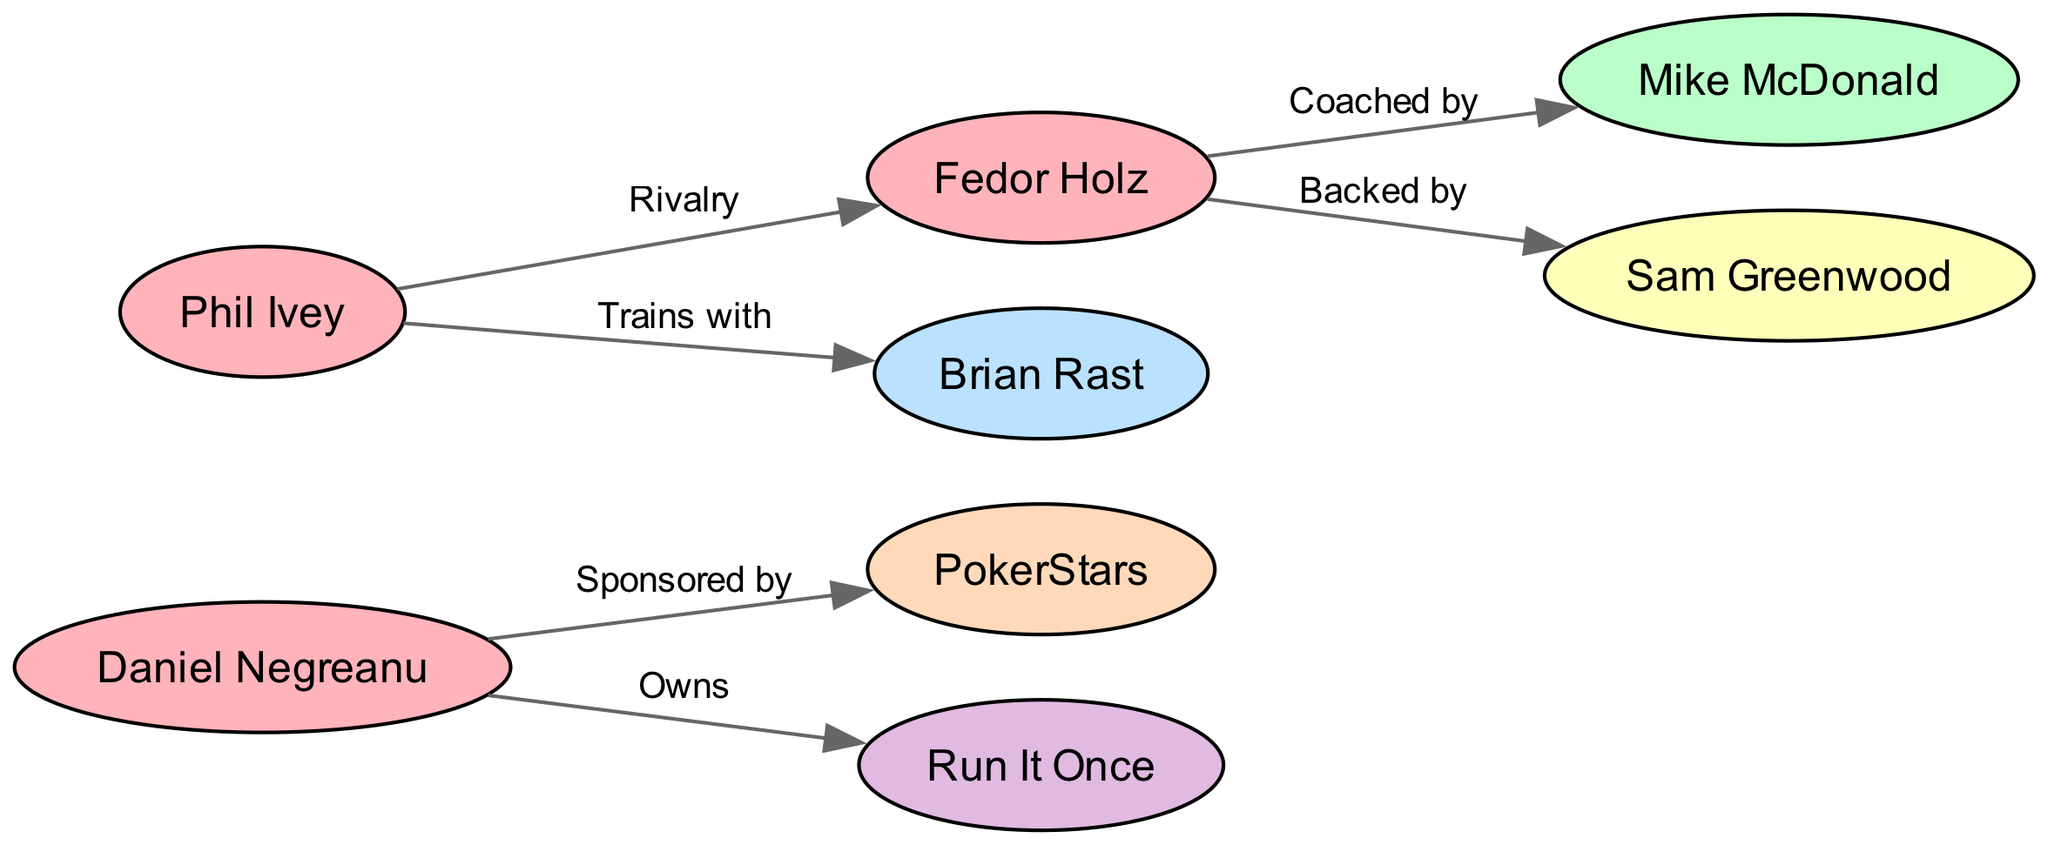What is the total number of players in the diagram? There are three players listed: Daniel Negreanu, Phil Ivey, and Fedor Holz. Counting them gives a total of three players.
Answer: 3 Who coaches Fedor Holz? The diagram shows an edge from Fedor Holz to Mike McDonald labeled "Coached by," indicating that Mike McDonald is the coach of Fedor Holz.
Answer: Mike McDonald Which player is sponsored by PokerStars? The diagram indicates that Daniel Negreanu has an edge labeled "Sponsored by" leading to PokerStars, meaning he is the player sponsored by that organization.
Answer: Daniel Negreanu How many edges connect the players in the diagram? Analyzing the edges, there are four connections that involve players: one is from Daniel Negreanu to PokerStars, and the others connect Phil Ivey to Brian Rast, Fedor Holz to his backer and coach, and the rivalry link between Phil Ivey and Fedor Holz. Thus, there are four edges.
Answer: 4 Who does Phil Ivey train with? The diagram illustrates an edge from Phil Ivey to Brian Rast, labeled "Trains with," meaning Brian Rast is the training partner for Phil Ivey.
Answer: Brian Rast Is there any player connected to a training site? Looking at the connections, Daniel Negreanu has an edge to Run It Once labeled "Owns," but there is no direct connection between any players and a training site for training purposes. Thus, no player has an explicit training site connection.
Answer: No Which player is backed by Sam Greenwood? The diagram directly shows Fedor Holz linked to Sam Greenwood with the label "Backed by." Therefore, Fedor Holz is the player backed by Sam Greenwood.
Answer: Fedor Holz What relationship type exists between Phil Ivey and Fedor Holz? The diagram indicates a connection labeled "Rivalry" between Phil Ivey and Fedor Holz, demonstrating a competitive relationship.
Answer: Rivalry How many different types of nodes are represented in the diagram? The nodes represent different types: Player, Coach, Training Partner, Backer, Sponsor, and Training Site. This totals to six distinct node types.
Answer: 6 